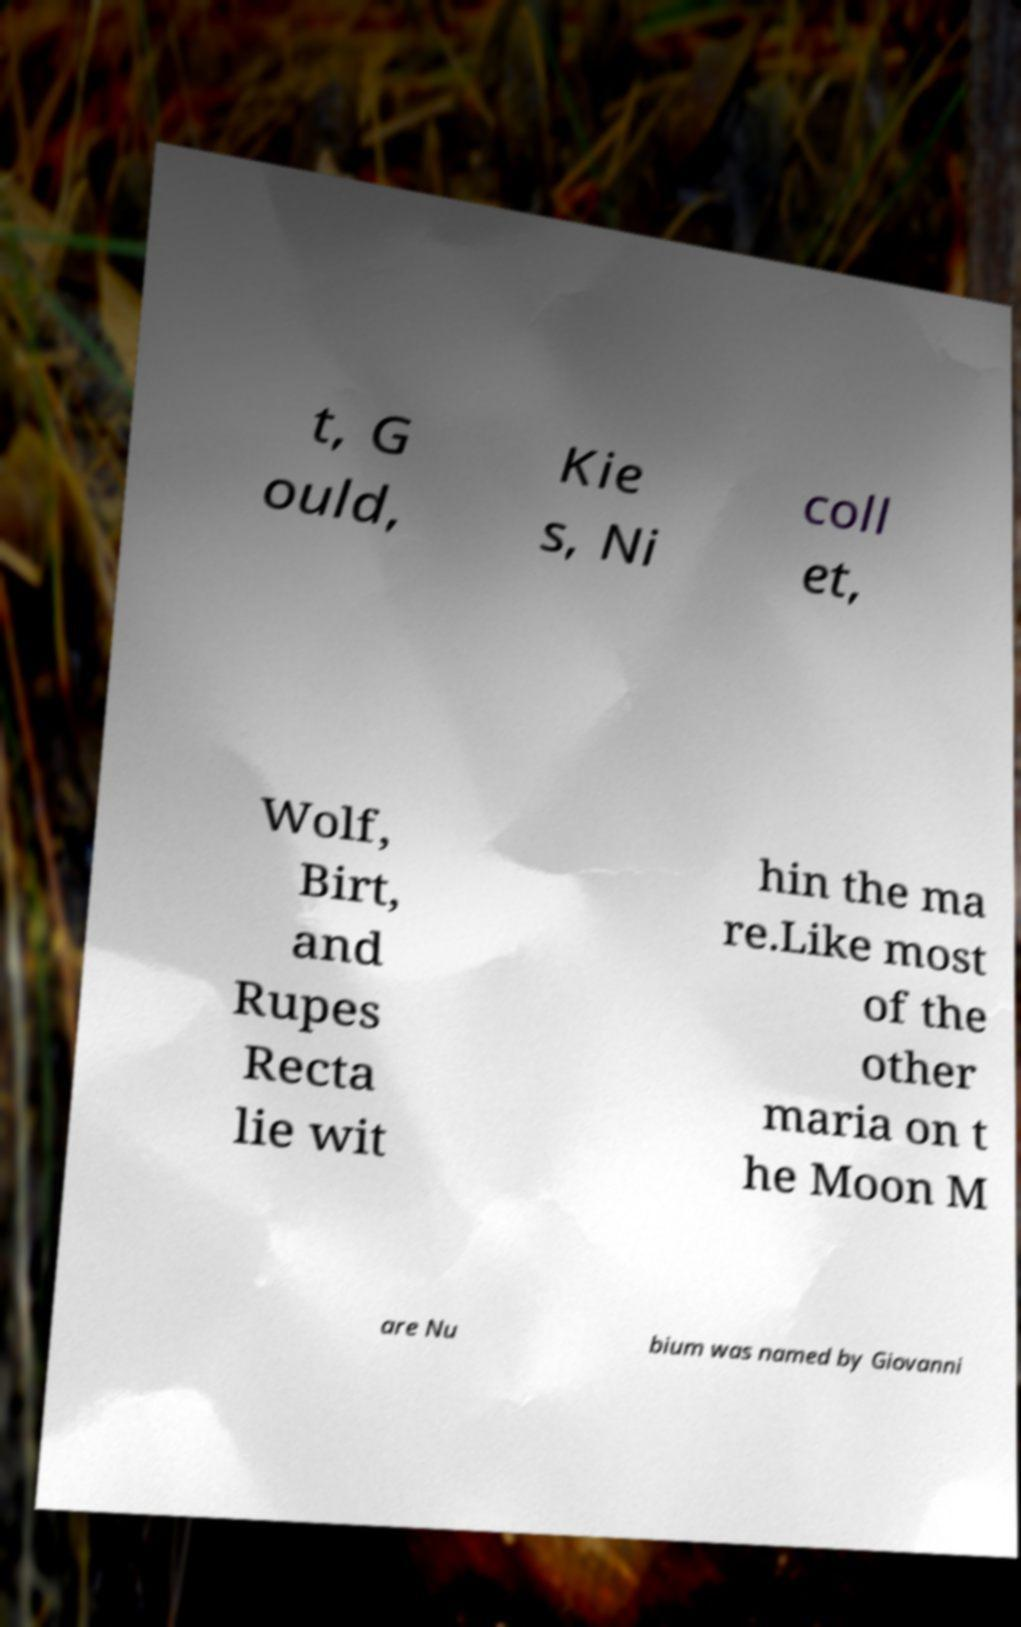For documentation purposes, I need the text within this image transcribed. Could you provide that? t, G ould, Kie s, Ni coll et, Wolf, Birt, and Rupes Recta lie wit hin the ma re.Like most of the other maria on t he Moon M are Nu bium was named by Giovanni 